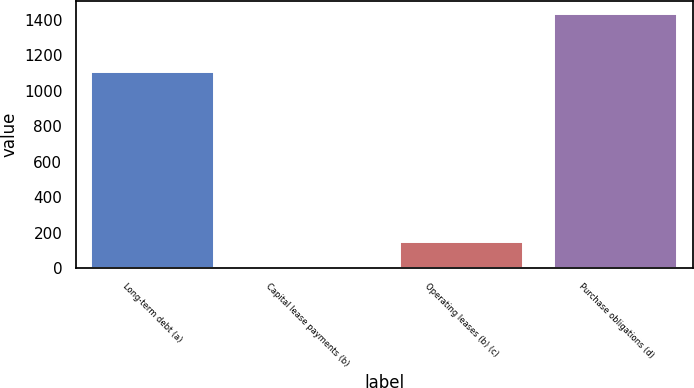Convert chart to OTSL. <chart><loc_0><loc_0><loc_500><loc_500><bar_chart><fcel>Long-term debt (a)<fcel>Capital lease payments (b)<fcel>Operating leases (b) (c)<fcel>Purchase obligations (d)<nl><fcel>1108<fcel>5<fcel>148<fcel>1435<nl></chart> 